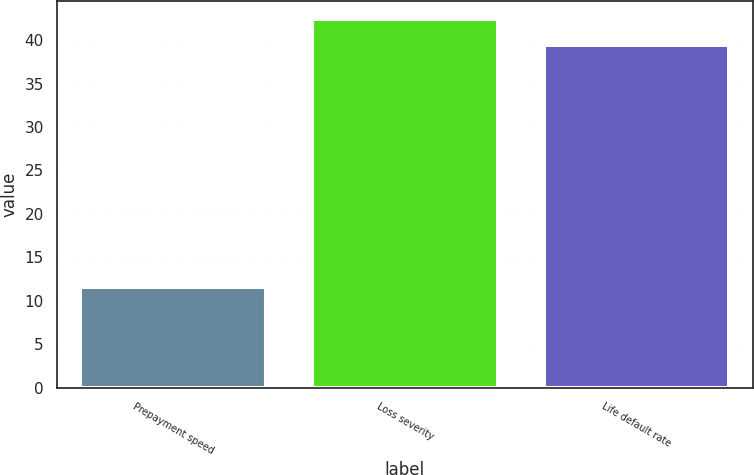<chart> <loc_0><loc_0><loc_500><loc_500><bar_chart><fcel>Prepayment speed<fcel>Loss severity<fcel>Life default rate<nl><fcel>11.6<fcel>42.37<fcel>39.4<nl></chart> 